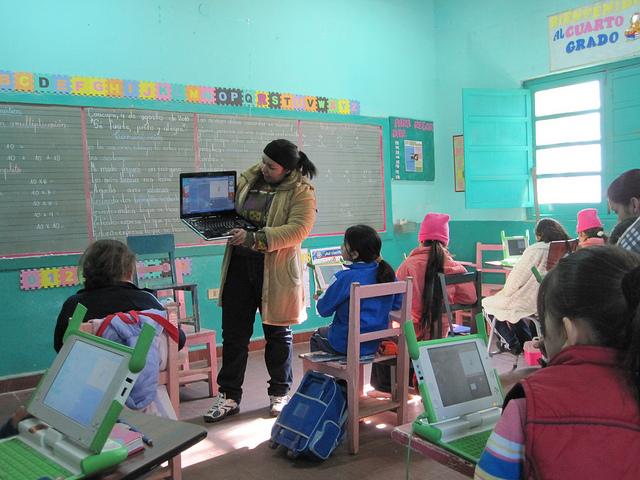What is the woman holding in her left hand?
Be succinct. Laptop. Are these college aged students?
Give a very brief answer. No. Do each student have a computer?
Concise answer only. Yes. Does the woman show the computer to the kids?
Answer briefly. Yes. 